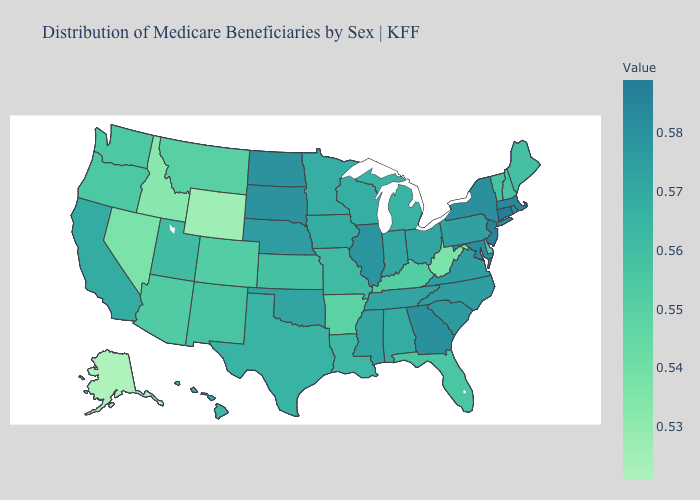Does Alaska have a lower value than New York?
Quick response, please. Yes. Which states have the lowest value in the MidWest?
Answer briefly. Kansas. Does Kentucky have a higher value than Minnesota?
Write a very short answer. No. Which states have the lowest value in the USA?
Give a very brief answer. Alaska. 